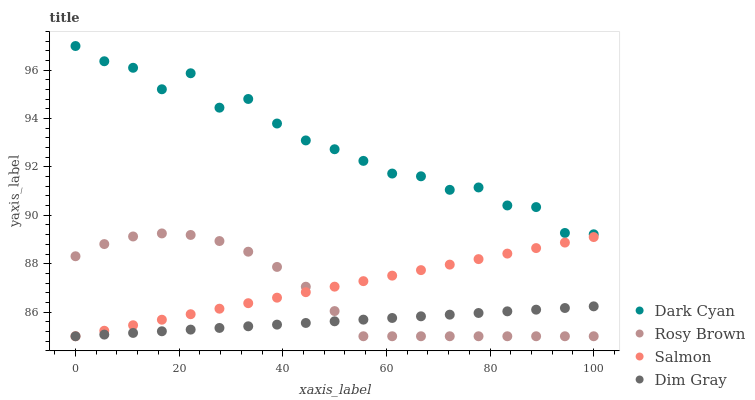Does Dim Gray have the minimum area under the curve?
Answer yes or no. Yes. Does Dark Cyan have the maximum area under the curve?
Answer yes or no. Yes. Does Rosy Brown have the minimum area under the curve?
Answer yes or no. No. Does Rosy Brown have the maximum area under the curve?
Answer yes or no. No. Is Dim Gray the smoothest?
Answer yes or no. Yes. Is Dark Cyan the roughest?
Answer yes or no. Yes. Is Rosy Brown the smoothest?
Answer yes or no. No. Is Rosy Brown the roughest?
Answer yes or no. No. Does Dim Gray have the lowest value?
Answer yes or no. Yes. Does Dark Cyan have the highest value?
Answer yes or no. Yes. Does Rosy Brown have the highest value?
Answer yes or no. No. Is Dim Gray less than Dark Cyan?
Answer yes or no. Yes. Is Dark Cyan greater than Rosy Brown?
Answer yes or no. Yes. Does Dim Gray intersect Salmon?
Answer yes or no. Yes. Is Dim Gray less than Salmon?
Answer yes or no. No. Is Dim Gray greater than Salmon?
Answer yes or no. No. Does Dim Gray intersect Dark Cyan?
Answer yes or no. No. 